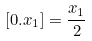Convert formula to latex. <formula><loc_0><loc_0><loc_500><loc_500>[ 0 . x _ { 1 } ] = \frac { x _ { 1 } } { 2 }</formula> 